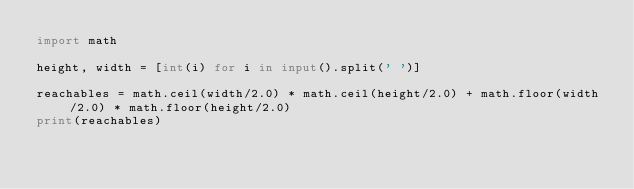Convert code to text. <code><loc_0><loc_0><loc_500><loc_500><_Python_>import math

height, width = [int(i) for i in input().split(' ')]

reachables = math.ceil(width/2.0) * math.ceil(height/2.0) + math.floor(width/2.0) * math.floor(height/2.0)
print(reachables)
</code> 